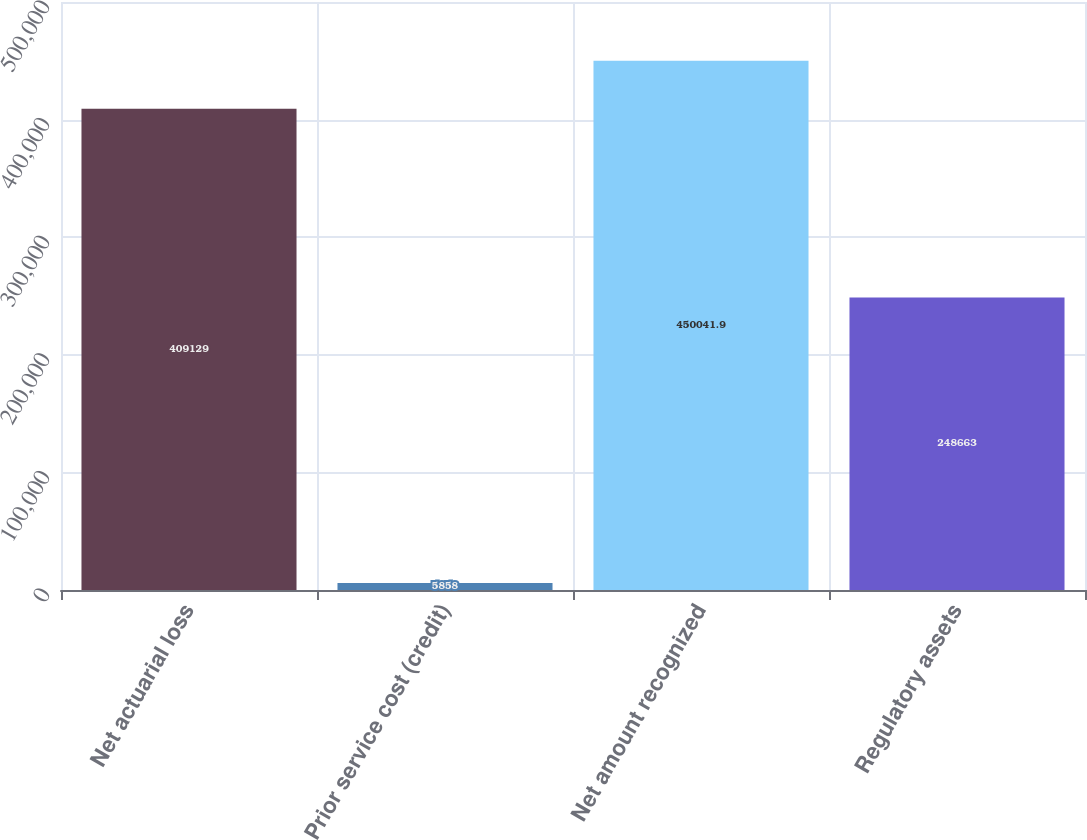<chart> <loc_0><loc_0><loc_500><loc_500><bar_chart><fcel>Net actuarial loss<fcel>Prior service cost (credit)<fcel>Net amount recognized<fcel>Regulatory assets<nl><fcel>409129<fcel>5858<fcel>450042<fcel>248663<nl></chart> 